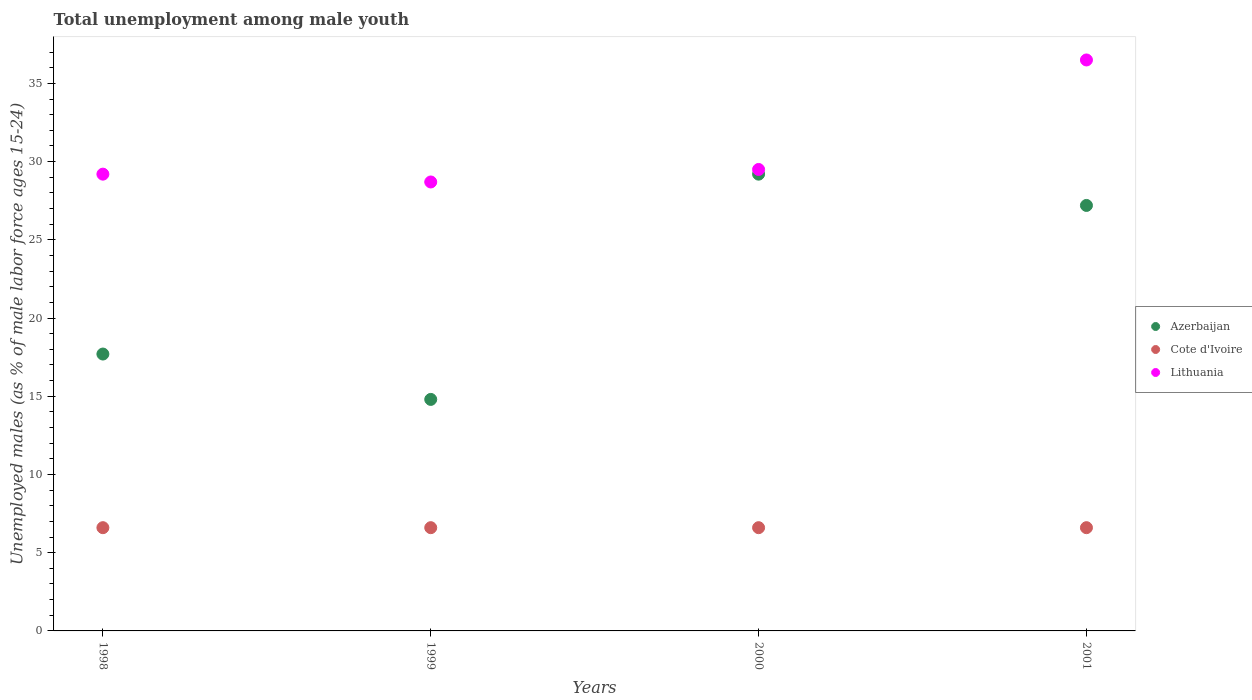How many different coloured dotlines are there?
Keep it short and to the point. 3. Is the number of dotlines equal to the number of legend labels?
Provide a succinct answer. Yes. What is the percentage of unemployed males in in Cote d'Ivoire in 2000?
Your answer should be very brief. 6.6. Across all years, what is the maximum percentage of unemployed males in in Azerbaijan?
Make the answer very short. 29.2. Across all years, what is the minimum percentage of unemployed males in in Azerbaijan?
Make the answer very short. 14.8. What is the total percentage of unemployed males in in Azerbaijan in the graph?
Keep it short and to the point. 88.9. What is the difference between the percentage of unemployed males in in Cote d'Ivoire in 1999 and the percentage of unemployed males in in Lithuania in 2000?
Your answer should be compact. -22.9. What is the average percentage of unemployed males in in Cote d'Ivoire per year?
Offer a terse response. 6.6. In the year 1998, what is the difference between the percentage of unemployed males in in Cote d'Ivoire and percentage of unemployed males in in Azerbaijan?
Make the answer very short. -11.1. Is the difference between the percentage of unemployed males in in Cote d'Ivoire in 1998 and 1999 greater than the difference between the percentage of unemployed males in in Azerbaijan in 1998 and 1999?
Provide a succinct answer. No. What is the difference between the highest and the lowest percentage of unemployed males in in Lithuania?
Ensure brevity in your answer.  7.8. Is the sum of the percentage of unemployed males in in Azerbaijan in 1999 and 2000 greater than the maximum percentage of unemployed males in in Cote d'Ivoire across all years?
Provide a succinct answer. Yes. Does the percentage of unemployed males in in Lithuania monotonically increase over the years?
Your answer should be very brief. No. Is the percentage of unemployed males in in Cote d'Ivoire strictly greater than the percentage of unemployed males in in Azerbaijan over the years?
Your answer should be compact. No. Is the percentage of unemployed males in in Lithuania strictly less than the percentage of unemployed males in in Azerbaijan over the years?
Make the answer very short. No. How many dotlines are there?
Make the answer very short. 3. How many legend labels are there?
Provide a short and direct response. 3. How are the legend labels stacked?
Make the answer very short. Vertical. What is the title of the graph?
Make the answer very short. Total unemployment among male youth. What is the label or title of the Y-axis?
Your response must be concise. Unemployed males (as % of male labor force ages 15-24). What is the Unemployed males (as % of male labor force ages 15-24) in Azerbaijan in 1998?
Ensure brevity in your answer.  17.7. What is the Unemployed males (as % of male labor force ages 15-24) of Cote d'Ivoire in 1998?
Your response must be concise. 6.6. What is the Unemployed males (as % of male labor force ages 15-24) of Lithuania in 1998?
Provide a short and direct response. 29.2. What is the Unemployed males (as % of male labor force ages 15-24) of Azerbaijan in 1999?
Give a very brief answer. 14.8. What is the Unemployed males (as % of male labor force ages 15-24) in Cote d'Ivoire in 1999?
Provide a short and direct response. 6.6. What is the Unemployed males (as % of male labor force ages 15-24) in Lithuania in 1999?
Offer a very short reply. 28.7. What is the Unemployed males (as % of male labor force ages 15-24) of Azerbaijan in 2000?
Your answer should be very brief. 29.2. What is the Unemployed males (as % of male labor force ages 15-24) of Cote d'Ivoire in 2000?
Offer a very short reply. 6.6. What is the Unemployed males (as % of male labor force ages 15-24) in Lithuania in 2000?
Give a very brief answer. 29.5. What is the Unemployed males (as % of male labor force ages 15-24) of Azerbaijan in 2001?
Your answer should be compact. 27.2. What is the Unemployed males (as % of male labor force ages 15-24) of Cote d'Ivoire in 2001?
Give a very brief answer. 6.6. What is the Unemployed males (as % of male labor force ages 15-24) in Lithuania in 2001?
Offer a terse response. 36.5. Across all years, what is the maximum Unemployed males (as % of male labor force ages 15-24) in Azerbaijan?
Your answer should be very brief. 29.2. Across all years, what is the maximum Unemployed males (as % of male labor force ages 15-24) of Cote d'Ivoire?
Provide a succinct answer. 6.6. Across all years, what is the maximum Unemployed males (as % of male labor force ages 15-24) of Lithuania?
Offer a terse response. 36.5. Across all years, what is the minimum Unemployed males (as % of male labor force ages 15-24) in Azerbaijan?
Your response must be concise. 14.8. Across all years, what is the minimum Unemployed males (as % of male labor force ages 15-24) in Cote d'Ivoire?
Offer a very short reply. 6.6. Across all years, what is the minimum Unemployed males (as % of male labor force ages 15-24) in Lithuania?
Your answer should be very brief. 28.7. What is the total Unemployed males (as % of male labor force ages 15-24) of Azerbaijan in the graph?
Provide a short and direct response. 88.9. What is the total Unemployed males (as % of male labor force ages 15-24) of Cote d'Ivoire in the graph?
Keep it short and to the point. 26.4. What is the total Unemployed males (as % of male labor force ages 15-24) of Lithuania in the graph?
Your answer should be very brief. 123.9. What is the difference between the Unemployed males (as % of male labor force ages 15-24) of Lithuania in 1998 and that in 1999?
Your answer should be very brief. 0.5. What is the difference between the Unemployed males (as % of male labor force ages 15-24) of Azerbaijan in 1998 and that in 2000?
Offer a very short reply. -11.5. What is the difference between the Unemployed males (as % of male labor force ages 15-24) of Cote d'Ivoire in 1998 and that in 2000?
Keep it short and to the point. 0. What is the difference between the Unemployed males (as % of male labor force ages 15-24) in Azerbaijan in 1998 and that in 2001?
Provide a succinct answer. -9.5. What is the difference between the Unemployed males (as % of male labor force ages 15-24) in Lithuania in 1998 and that in 2001?
Make the answer very short. -7.3. What is the difference between the Unemployed males (as % of male labor force ages 15-24) of Azerbaijan in 1999 and that in 2000?
Keep it short and to the point. -14.4. What is the difference between the Unemployed males (as % of male labor force ages 15-24) of Cote d'Ivoire in 1999 and that in 2000?
Keep it short and to the point. 0. What is the difference between the Unemployed males (as % of male labor force ages 15-24) in Lithuania in 1999 and that in 2000?
Make the answer very short. -0.8. What is the difference between the Unemployed males (as % of male labor force ages 15-24) of Azerbaijan in 1999 and that in 2001?
Provide a succinct answer. -12.4. What is the difference between the Unemployed males (as % of male labor force ages 15-24) of Cote d'Ivoire in 1999 and that in 2001?
Make the answer very short. 0. What is the difference between the Unemployed males (as % of male labor force ages 15-24) in Cote d'Ivoire in 2000 and that in 2001?
Offer a terse response. 0. What is the difference between the Unemployed males (as % of male labor force ages 15-24) in Lithuania in 2000 and that in 2001?
Keep it short and to the point. -7. What is the difference between the Unemployed males (as % of male labor force ages 15-24) in Azerbaijan in 1998 and the Unemployed males (as % of male labor force ages 15-24) in Lithuania in 1999?
Make the answer very short. -11. What is the difference between the Unemployed males (as % of male labor force ages 15-24) in Cote d'Ivoire in 1998 and the Unemployed males (as % of male labor force ages 15-24) in Lithuania in 1999?
Offer a terse response. -22.1. What is the difference between the Unemployed males (as % of male labor force ages 15-24) of Azerbaijan in 1998 and the Unemployed males (as % of male labor force ages 15-24) of Cote d'Ivoire in 2000?
Give a very brief answer. 11.1. What is the difference between the Unemployed males (as % of male labor force ages 15-24) in Cote d'Ivoire in 1998 and the Unemployed males (as % of male labor force ages 15-24) in Lithuania in 2000?
Offer a terse response. -22.9. What is the difference between the Unemployed males (as % of male labor force ages 15-24) in Azerbaijan in 1998 and the Unemployed males (as % of male labor force ages 15-24) in Cote d'Ivoire in 2001?
Your answer should be compact. 11.1. What is the difference between the Unemployed males (as % of male labor force ages 15-24) of Azerbaijan in 1998 and the Unemployed males (as % of male labor force ages 15-24) of Lithuania in 2001?
Offer a very short reply. -18.8. What is the difference between the Unemployed males (as % of male labor force ages 15-24) in Cote d'Ivoire in 1998 and the Unemployed males (as % of male labor force ages 15-24) in Lithuania in 2001?
Your answer should be very brief. -29.9. What is the difference between the Unemployed males (as % of male labor force ages 15-24) of Azerbaijan in 1999 and the Unemployed males (as % of male labor force ages 15-24) of Cote d'Ivoire in 2000?
Your response must be concise. 8.2. What is the difference between the Unemployed males (as % of male labor force ages 15-24) of Azerbaijan in 1999 and the Unemployed males (as % of male labor force ages 15-24) of Lithuania in 2000?
Your answer should be very brief. -14.7. What is the difference between the Unemployed males (as % of male labor force ages 15-24) in Cote d'Ivoire in 1999 and the Unemployed males (as % of male labor force ages 15-24) in Lithuania in 2000?
Provide a succinct answer. -22.9. What is the difference between the Unemployed males (as % of male labor force ages 15-24) of Azerbaijan in 1999 and the Unemployed males (as % of male labor force ages 15-24) of Lithuania in 2001?
Provide a short and direct response. -21.7. What is the difference between the Unemployed males (as % of male labor force ages 15-24) of Cote d'Ivoire in 1999 and the Unemployed males (as % of male labor force ages 15-24) of Lithuania in 2001?
Provide a short and direct response. -29.9. What is the difference between the Unemployed males (as % of male labor force ages 15-24) of Azerbaijan in 2000 and the Unemployed males (as % of male labor force ages 15-24) of Cote d'Ivoire in 2001?
Your answer should be compact. 22.6. What is the difference between the Unemployed males (as % of male labor force ages 15-24) of Cote d'Ivoire in 2000 and the Unemployed males (as % of male labor force ages 15-24) of Lithuania in 2001?
Offer a terse response. -29.9. What is the average Unemployed males (as % of male labor force ages 15-24) in Azerbaijan per year?
Provide a short and direct response. 22.23. What is the average Unemployed males (as % of male labor force ages 15-24) of Cote d'Ivoire per year?
Make the answer very short. 6.6. What is the average Unemployed males (as % of male labor force ages 15-24) in Lithuania per year?
Ensure brevity in your answer.  30.98. In the year 1998, what is the difference between the Unemployed males (as % of male labor force ages 15-24) of Cote d'Ivoire and Unemployed males (as % of male labor force ages 15-24) of Lithuania?
Keep it short and to the point. -22.6. In the year 1999, what is the difference between the Unemployed males (as % of male labor force ages 15-24) in Azerbaijan and Unemployed males (as % of male labor force ages 15-24) in Cote d'Ivoire?
Give a very brief answer. 8.2. In the year 1999, what is the difference between the Unemployed males (as % of male labor force ages 15-24) in Azerbaijan and Unemployed males (as % of male labor force ages 15-24) in Lithuania?
Your response must be concise. -13.9. In the year 1999, what is the difference between the Unemployed males (as % of male labor force ages 15-24) in Cote d'Ivoire and Unemployed males (as % of male labor force ages 15-24) in Lithuania?
Give a very brief answer. -22.1. In the year 2000, what is the difference between the Unemployed males (as % of male labor force ages 15-24) of Azerbaijan and Unemployed males (as % of male labor force ages 15-24) of Cote d'Ivoire?
Keep it short and to the point. 22.6. In the year 2000, what is the difference between the Unemployed males (as % of male labor force ages 15-24) in Cote d'Ivoire and Unemployed males (as % of male labor force ages 15-24) in Lithuania?
Offer a very short reply. -22.9. In the year 2001, what is the difference between the Unemployed males (as % of male labor force ages 15-24) of Azerbaijan and Unemployed males (as % of male labor force ages 15-24) of Cote d'Ivoire?
Provide a succinct answer. 20.6. In the year 2001, what is the difference between the Unemployed males (as % of male labor force ages 15-24) in Cote d'Ivoire and Unemployed males (as % of male labor force ages 15-24) in Lithuania?
Make the answer very short. -29.9. What is the ratio of the Unemployed males (as % of male labor force ages 15-24) in Azerbaijan in 1998 to that in 1999?
Your answer should be compact. 1.2. What is the ratio of the Unemployed males (as % of male labor force ages 15-24) in Cote d'Ivoire in 1998 to that in 1999?
Make the answer very short. 1. What is the ratio of the Unemployed males (as % of male labor force ages 15-24) of Lithuania in 1998 to that in 1999?
Make the answer very short. 1.02. What is the ratio of the Unemployed males (as % of male labor force ages 15-24) of Azerbaijan in 1998 to that in 2000?
Make the answer very short. 0.61. What is the ratio of the Unemployed males (as % of male labor force ages 15-24) of Azerbaijan in 1998 to that in 2001?
Ensure brevity in your answer.  0.65. What is the ratio of the Unemployed males (as % of male labor force ages 15-24) of Azerbaijan in 1999 to that in 2000?
Make the answer very short. 0.51. What is the ratio of the Unemployed males (as % of male labor force ages 15-24) in Lithuania in 1999 to that in 2000?
Ensure brevity in your answer.  0.97. What is the ratio of the Unemployed males (as % of male labor force ages 15-24) in Azerbaijan in 1999 to that in 2001?
Your answer should be compact. 0.54. What is the ratio of the Unemployed males (as % of male labor force ages 15-24) of Cote d'Ivoire in 1999 to that in 2001?
Keep it short and to the point. 1. What is the ratio of the Unemployed males (as % of male labor force ages 15-24) of Lithuania in 1999 to that in 2001?
Keep it short and to the point. 0.79. What is the ratio of the Unemployed males (as % of male labor force ages 15-24) in Azerbaijan in 2000 to that in 2001?
Offer a very short reply. 1.07. What is the ratio of the Unemployed males (as % of male labor force ages 15-24) of Lithuania in 2000 to that in 2001?
Provide a succinct answer. 0.81. What is the difference between the highest and the second highest Unemployed males (as % of male labor force ages 15-24) in Cote d'Ivoire?
Your response must be concise. 0. 